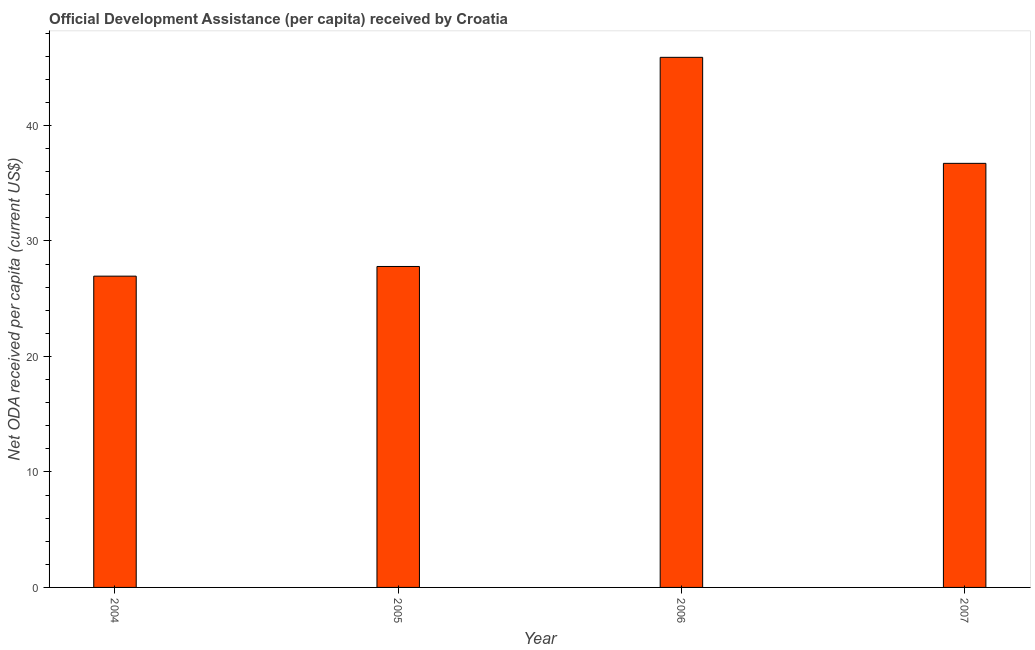Does the graph contain any zero values?
Your answer should be compact. No. Does the graph contain grids?
Provide a short and direct response. No. What is the title of the graph?
Make the answer very short. Official Development Assistance (per capita) received by Croatia. What is the label or title of the Y-axis?
Ensure brevity in your answer.  Net ODA received per capita (current US$). What is the net oda received per capita in 2004?
Ensure brevity in your answer.  26.96. Across all years, what is the maximum net oda received per capita?
Provide a succinct answer. 45.91. Across all years, what is the minimum net oda received per capita?
Keep it short and to the point. 26.96. In which year was the net oda received per capita minimum?
Provide a short and direct response. 2004. What is the sum of the net oda received per capita?
Make the answer very short. 137.38. What is the difference between the net oda received per capita in 2004 and 2005?
Make the answer very short. -0.84. What is the average net oda received per capita per year?
Keep it short and to the point. 34.34. What is the median net oda received per capita?
Ensure brevity in your answer.  32.26. What is the ratio of the net oda received per capita in 2004 to that in 2007?
Keep it short and to the point. 0.73. Is the net oda received per capita in 2004 less than that in 2007?
Offer a terse response. Yes. Is the difference between the net oda received per capita in 2006 and 2007 greater than the difference between any two years?
Make the answer very short. No. What is the difference between the highest and the second highest net oda received per capita?
Keep it short and to the point. 9.18. Is the sum of the net oda received per capita in 2005 and 2007 greater than the maximum net oda received per capita across all years?
Provide a short and direct response. Yes. What is the difference between the highest and the lowest net oda received per capita?
Your response must be concise. 18.95. How many bars are there?
Give a very brief answer. 4. Are all the bars in the graph horizontal?
Keep it short and to the point. No. What is the difference between two consecutive major ticks on the Y-axis?
Provide a short and direct response. 10. What is the Net ODA received per capita (current US$) of 2004?
Give a very brief answer. 26.96. What is the Net ODA received per capita (current US$) in 2005?
Offer a very short reply. 27.79. What is the Net ODA received per capita (current US$) of 2006?
Your answer should be compact. 45.91. What is the Net ODA received per capita (current US$) of 2007?
Offer a terse response. 36.72. What is the difference between the Net ODA received per capita (current US$) in 2004 and 2005?
Give a very brief answer. -0.84. What is the difference between the Net ODA received per capita (current US$) in 2004 and 2006?
Your answer should be very brief. -18.95. What is the difference between the Net ODA received per capita (current US$) in 2004 and 2007?
Provide a succinct answer. -9.77. What is the difference between the Net ODA received per capita (current US$) in 2005 and 2006?
Ensure brevity in your answer.  -18.11. What is the difference between the Net ODA received per capita (current US$) in 2005 and 2007?
Your answer should be very brief. -8.93. What is the difference between the Net ODA received per capita (current US$) in 2006 and 2007?
Give a very brief answer. 9.18. What is the ratio of the Net ODA received per capita (current US$) in 2004 to that in 2006?
Keep it short and to the point. 0.59. What is the ratio of the Net ODA received per capita (current US$) in 2004 to that in 2007?
Give a very brief answer. 0.73. What is the ratio of the Net ODA received per capita (current US$) in 2005 to that in 2006?
Offer a very short reply. 0.6. What is the ratio of the Net ODA received per capita (current US$) in 2005 to that in 2007?
Make the answer very short. 0.76. What is the ratio of the Net ODA received per capita (current US$) in 2006 to that in 2007?
Give a very brief answer. 1.25. 